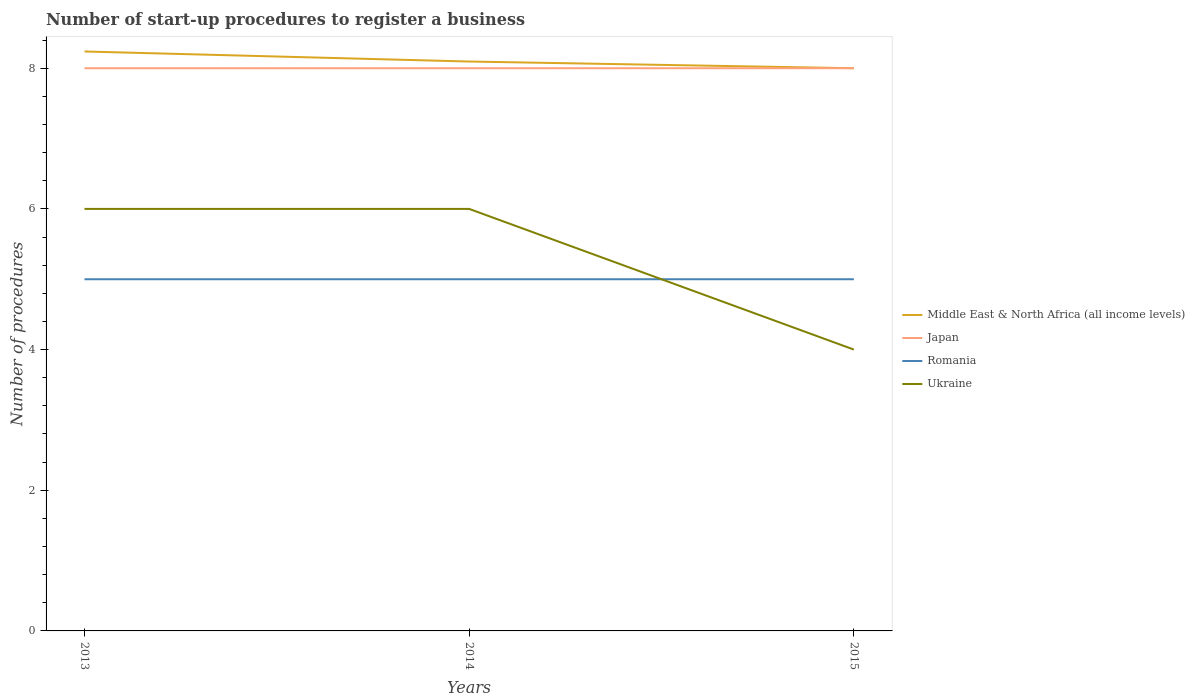How many different coloured lines are there?
Offer a very short reply. 4. Does the line corresponding to Ukraine intersect with the line corresponding to Romania?
Ensure brevity in your answer.  Yes. In which year was the number of procedures required to register a business in Romania maximum?
Provide a short and direct response. 2013. What is the total number of procedures required to register a business in Ukraine in the graph?
Provide a short and direct response. 0. What is the difference between the highest and the second highest number of procedures required to register a business in Romania?
Your response must be concise. 0. What is the difference between the highest and the lowest number of procedures required to register a business in Middle East & North Africa (all income levels)?
Give a very brief answer. 1. Is the number of procedures required to register a business in Romania strictly greater than the number of procedures required to register a business in Ukraine over the years?
Offer a terse response. No. Are the values on the major ticks of Y-axis written in scientific E-notation?
Ensure brevity in your answer.  No. Does the graph contain grids?
Give a very brief answer. No. How many legend labels are there?
Your answer should be compact. 4. How are the legend labels stacked?
Offer a terse response. Vertical. What is the title of the graph?
Provide a succinct answer. Number of start-up procedures to register a business. Does "United States" appear as one of the legend labels in the graph?
Your response must be concise. No. What is the label or title of the X-axis?
Keep it short and to the point. Years. What is the label or title of the Y-axis?
Provide a short and direct response. Number of procedures. What is the Number of procedures in Middle East & North Africa (all income levels) in 2013?
Ensure brevity in your answer.  8.24. What is the Number of procedures of Japan in 2013?
Provide a succinct answer. 8. What is the Number of procedures in Middle East & North Africa (all income levels) in 2014?
Your answer should be compact. 8.1. What is the Number of procedures in Romania in 2014?
Your response must be concise. 5. Across all years, what is the maximum Number of procedures of Middle East & North Africa (all income levels)?
Provide a succinct answer. 8.24. Across all years, what is the maximum Number of procedures of Japan?
Offer a terse response. 8. Across all years, what is the maximum Number of procedures in Ukraine?
Provide a succinct answer. 6. Across all years, what is the minimum Number of procedures of Middle East & North Africa (all income levels)?
Give a very brief answer. 8. Across all years, what is the minimum Number of procedures in Romania?
Give a very brief answer. 5. Across all years, what is the minimum Number of procedures in Ukraine?
Offer a terse response. 4. What is the total Number of procedures of Middle East & North Africa (all income levels) in the graph?
Ensure brevity in your answer.  24.33. What is the total Number of procedures in Japan in the graph?
Ensure brevity in your answer.  24. What is the total Number of procedures in Ukraine in the graph?
Your answer should be very brief. 16. What is the difference between the Number of procedures in Middle East & North Africa (all income levels) in 2013 and that in 2014?
Provide a short and direct response. 0.14. What is the difference between the Number of procedures of Middle East & North Africa (all income levels) in 2013 and that in 2015?
Ensure brevity in your answer.  0.24. What is the difference between the Number of procedures in Ukraine in 2013 and that in 2015?
Offer a very short reply. 2. What is the difference between the Number of procedures of Middle East & North Africa (all income levels) in 2014 and that in 2015?
Ensure brevity in your answer.  0.1. What is the difference between the Number of procedures of Romania in 2014 and that in 2015?
Ensure brevity in your answer.  0. What is the difference between the Number of procedures in Ukraine in 2014 and that in 2015?
Offer a terse response. 2. What is the difference between the Number of procedures of Middle East & North Africa (all income levels) in 2013 and the Number of procedures of Japan in 2014?
Keep it short and to the point. 0.24. What is the difference between the Number of procedures in Middle East & North Africa (all income levels) in 2013 and the Number of procedures in Romania in 2014?
Give a very brief answer. 3.24. What is the difference between the Number of procedures in Middle East & North Africa (all income levels) in 2013 and the Number of procedures in Ukraine in 2014?
Keep it short and to the point. 2.24. What is the difference between the Number of procedures in Middle East & North Africa (all income levels) in 2013 and the Number of procedures in Japan in 2015?
Offer a very short reply. 0.24. What is the difference between the Number of procedures in Middle East & North Africa (all income levels) in 2013 and the Number of procedures in Romania in 2015?
Offer a very short reply. 3.24. What is the difference between the Number of procedures of Middle East & North Africa (all income levels) in 2013 and the Number of procedures of Ukraine in 2015?
Offer a very short reply. 4.24. What is the difference between the Number of procedures of Japan in 2013 and the Number of procedures of Romania in 2015?
Keep it short and to the point. 3. What is the difference between the Number of procedures in Romania in 2013 and the Number of procedures in Ukraine in 2015?
Ensure brevity in your answer.  1. What is the difference between the Number of procedures in Middle East & North Africa (all income levels) in 2014 and the Number of procedures in Japan in 2015?
Offer a terse response. 0.1. What is the difference between the Number of procedures of Middle East & North Africa (all income levels) in 2014 and the Number of procedures of Romania in 2015?
Make the answer very short. 3.1. What is the difference between the Number of procedures of Middle East & North Africa (all income levels) in 2014 and the Number of procedures of Ukraine in 2015?
Your answer should be compact. 4.1. What is the difference between the Number of procedures of Japan in 2014 and the Number of procedures of Ukraine in 2015?
Your answer should be compact. 4. What is the difference between the Number of procedures in Romania in 2014 and the Number of procedures in Ukraine in 2015?
Offer a terse response. 1. What is the average Number of procedures in Middle East & North Africa (all income levels) per year?
Offer a terse response. 8.11. What is the average Number of procedures in Japan per year?
Offer a terse response. 8. What is the average Number of procedures in Ukraine per year?
Offer a very short reply. 5.33. In the year 2013, what is the difference between the Number of procedures in Middle East & North Africa (all income levels) and Number of procedures in Japan?
Provide a succinct answer. 0.24. In the year 2013, what is the difference between the Number of procedures of Middle East & North Africa (all income levels) and Number of procedures of Romania?
Provide a succinct answer. 3.24. In the year 2013, what is the difference between the Number of procedures in Middle East & North Africa (all income levels) and Number of procedures in Ukraine?
Ensure brevity in your answer.  2.24. In the year 2013, what is the difference between the Number of procedures of Japan and Number of procedures of Ukraine?
Your answer should be very brief. 2. In the year 2014, what is the difference between the Number of procedures in Middle East & North Africa (all income levels) and Number of procedures in Japan?
Offer a terse response. 0.1. In the year 2014, what is the difference between the Number of procedures in Middle East & North Africa (all income levels) and Number of procedures in Romania?
Your answer should be very brief. 3.1. In the year 2014, what is the difference between the Number of procedures in Middle East & North Africa (all income levels) and Number of procedures in Ukraine?
Keep it short and to the point. 2.1. In the year 2014, what is the difference between the Number of procedures in Japan and Number of procedures in Romania?
Offer a very short reply. 3. In the year 2014, what is the difference between the Number of procedures of Japan and Number of procedures of Ukraine?
Ensure brevity in your answer.  2. In the year 2015, what is the difference between the Number of procedures of Middle East & North Africa (all income levels) and Number of procedures of Japan?
Your response must be concise. 0. In the year 2015, what is the difference between the Number of procedures of Middle East & North Africa (all income levels) and Number of procedures of Romania?
Make the answer very short. 3. In the year 2015, what is the difference between the Number of procedures in Japan and Number of procedures in Romania?
Your answer should be compact. 3. In the year 2015, what is the difference between the Number of procedures of Japan and Number of procedures of Ukraine?
Provide a short and direct response. 4. In the year 2015, what is the difference between the Number of procedures in Romania and Number of procedures in Ukraine?
Your answer should be very brief. 1. What is the ratio of the Number of procedures in Middle East & North Africa (all income levels) in 2013 to that in 2014?
Provide a short and direct response. 1.02. What is the ratio of the Number of procedures in Middle East & North Africa (all income levels) in 2013 to that in 2015?
Offer a terse response. 1.03. What is the ratio of the Number of procedures in Romania in 2013 to that in 2015?
Your answer should be compact. 1. What is the ratio of the Number of procedures in Middle East & North Africa (all income levels) in 2014 to that in 2015?
Provide a succinct answer. 1.01. What is the ratio of the Number of procedures in Romania in 2014 to that in 2015?
Make the answer very short. 1. What is the ratio of the Number of procedures of Ukraine in 2014 to that in 2015?
Give a very brief answer. 1.5. What is the difference between the highest and the second highest Number of procedures in Middle East & North Africa (all income levels)?
Ensure brevity in your answer.  0.14. What is the difference between the highest and the second highest Number of procedures of Japan?
Your response must be concise. 0. What is the difference between the highest and the lowest Number of procedures of Middle East & North Africa (all income levels)?
Offer a very short reply. 0.24. What is the difference between the highest and the lowest Number of procedures in Romania?
Offer a very short reply. 0. 